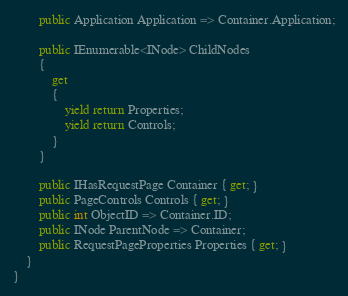Convert code to text. <code><loc_0><loc_0><loc_500><loc_500><_C#_>        public Application Application => Container.Application;

        public IEnumerable<INode> ChildNodes
        {
            get
            {
                yield return Properties;
                yield return Controls;
            }
        }

        public IHasRequestPage Container { get; }
        public PageControls Controls { get; }
        public int ObjectID => Container.ID;
        public INode ParentNode => Container;
        public RequestPageProperties Properties { get; }
    }
}</code> 